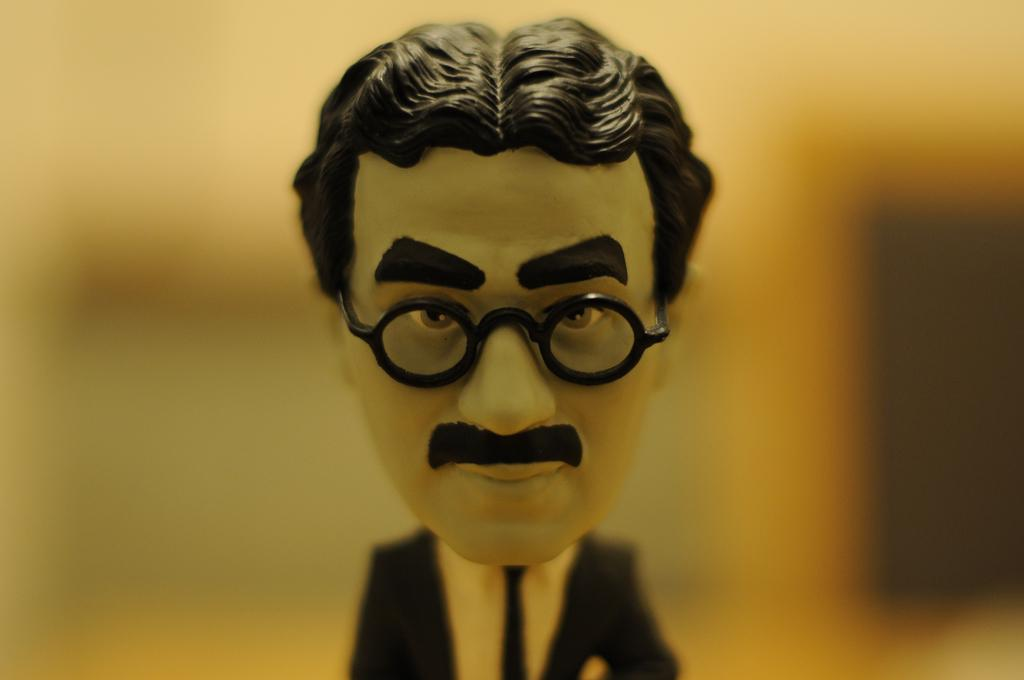What type of doll is in the image? The doll in the image is of a man. What accessories does the doll have? The doll has opticals, a mustache, and is wearing a black blazer, a tie, and a white shirt. Can you describe the doll's attire? The doll is wearing a black blazer, a tie, and a white shirt. Is the background behind the doll clearly visible? No, the background behind the doll is not clearly visible. What type of magic does the doll perform in the image? There is no magic or any indication of magic in the image; it simply features a doll with specific accessories and attire. 